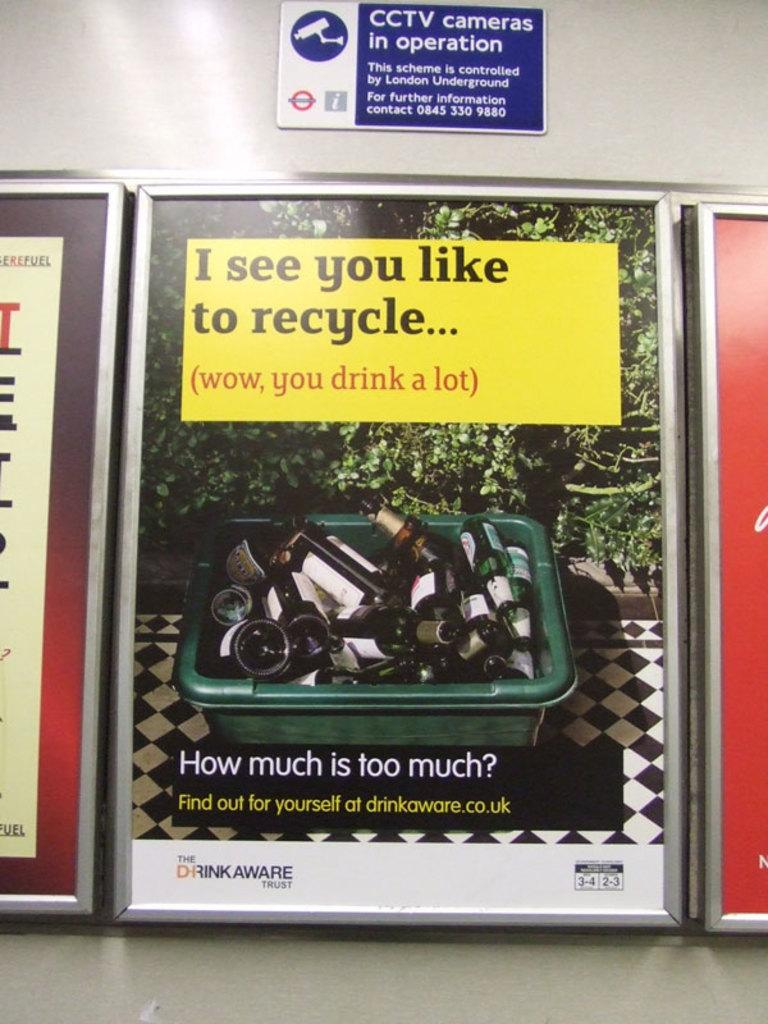What type of image is being described? The image is a banner. What can be seen in the plastic tub in the image? There are beer bottles in a plastic tub in the image. Are there any other elements in the image besides the beer bottles and banner? Yes, there are other plants present in the image. How does the sand interact with the beer bottles during the show in the image? There is no sand or show present in the image; it features a banner with beer bottles in a plastic tub and other plants. 